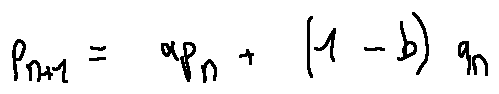Convert formula to latex. <formula><loc_0><loc_0><loc_500><loc_500>p _ { n + 1 } = a p _ { n } + ( 1 - b ) q _ { n }</formula> 